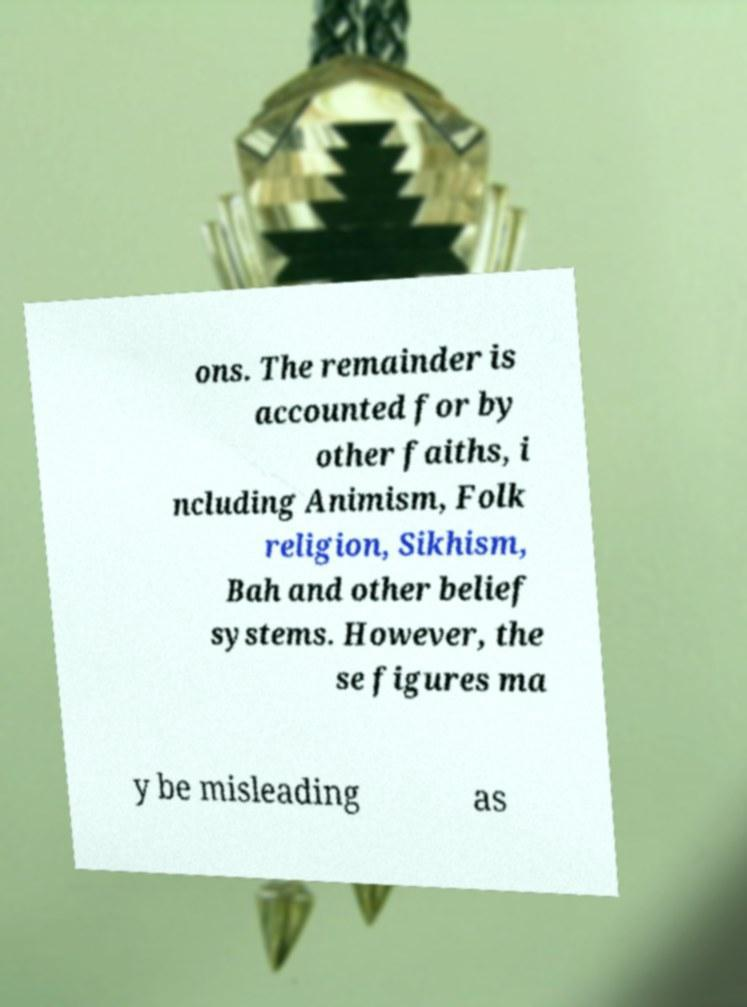Can you accurately transcribe the text from the provided image for me? ons. The remainder is accounted for by other faiths, i ncluding Animism, Folk religion, Sikhism, Bah and other belief systems. However, the se figures ma y be misleading as 